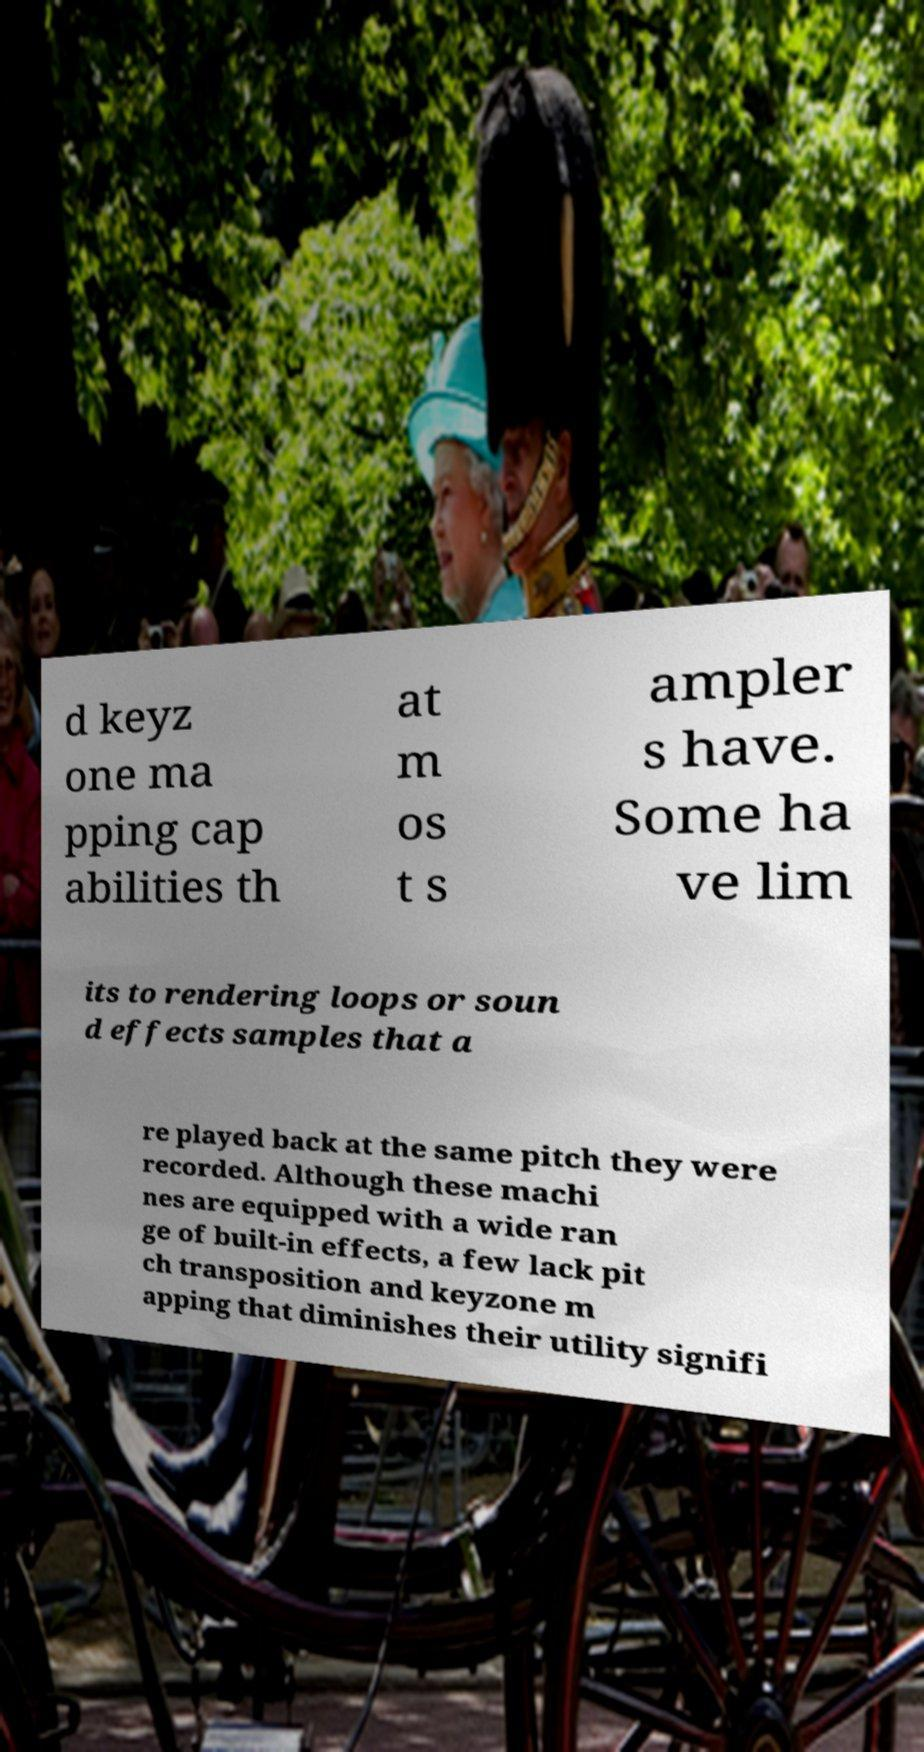Can you accurately transcribe the text from the provided image for me? d keyz one ma pping cap abilities th at m os t s ampler s have. Some ha ve lim its to rendering loops or soun d effects samples that a re played back at the same pitch they were recorded. Although these machi nes are equipped with a wide ran ge of built-in effects, a few lack pit ch transposition and keyzone m apping that diminishes their utility signifi 